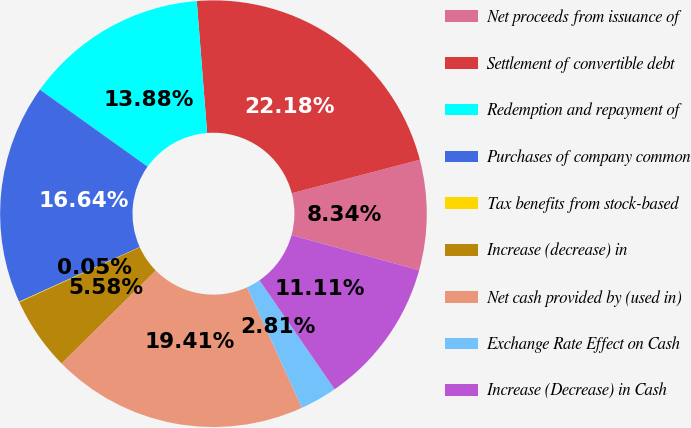Convert chart. <chart><loc_0><loc_0><loc_500><loc_500><pie_chart><fcel>Net proceeds from issuance of<fcel>Settlement of convertible debt<fcel>Redemption and repayment of<fcel>Purchases of company common<fcel>Tax benefits from stock-based<fcel>Increase (decrease) in<fcel>Net cash provided by (used in)<fcel>Exchange Rate Effect on Cash<fcel>Increase (Decrease) in Cash<nl><fcel>8.34%<fcel>22.18%<fcel>13.88%<fcel>16.64%<fcel>0.05%<fcel>5.58%<fcel>19.41%<fcel>2.81%<fcel>11.11%<nl></chart> 